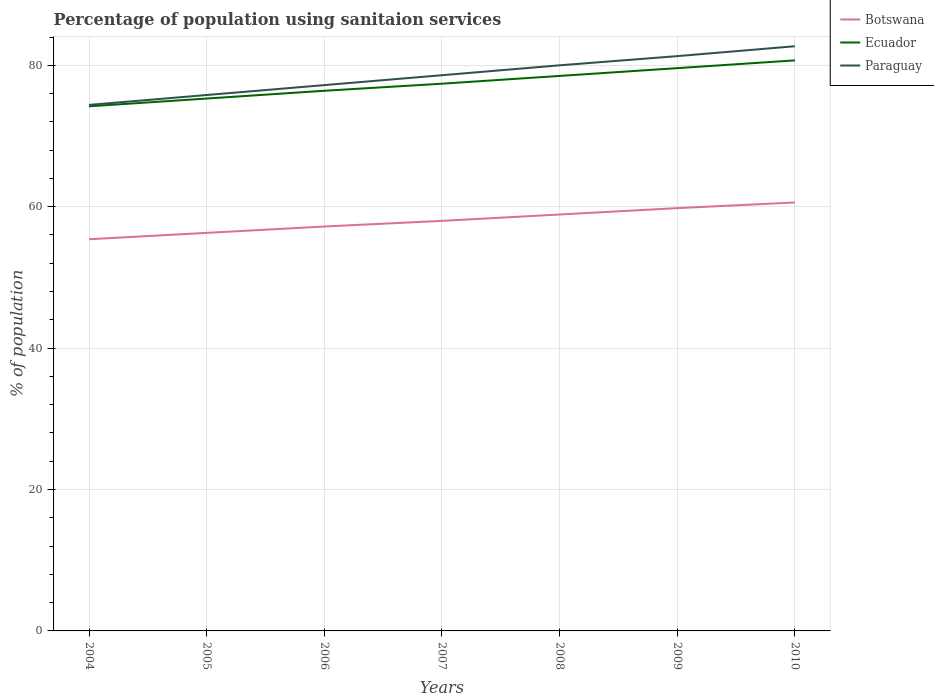How many different coloured lines are there?
Your answer should be very brief. 3. Does the line corresponding to Botswana intersect with the line corresponding to Ecuador?
Give a very brief answer. No. Across all years, what is the maximum percentage of population using sanitaion services in Paraguay?
Provide a succinct answer. 74.4. In which year was the percentage of population using sanitaion services in Ecuador maximum?
Your answer should be compact. 2004. What is the total percentage of population using sanitaion services in Ecuador in the graph?
Your answer should be compact. -5.4. What is the difference between the highest and the second highest percentage of population using sanitaion services in Botswana?
Provide a succinct answer. 5.2. What is the difference between the highest and the lowest percentage of population using sanitaion services in Ecuador?
Offer a very short reply. 3. How many years are there in the graph?
Provide a succinct answer. 7. Does the graph contain any zero values?
Offer a terse response. No. Does the graph contain grids?
Your answer should be compact. Yes. What is the title of the graph?
Provide a short and direct response. Percentage of population using sanitaion services. Does "Finland" appear as one of the legend labels in the graph?
Give a very brief answer. No. What is the label or title of the X-axis?
Offer a terse response. Years. What is the label or title of the Y-axis?
Provide a succinct answer. % of population. What is the % of population in Botswana in 2004?
Offer a very short reply. 55.4. What is the % of population in Ecuador in 2004?
Ensure brevity in your answer.  74.2. What is the % of population in Paraguay in 2004?
Provide a short and direct response. 74.4. What is the % of population in Botswana in 2005?
Ensure brevity in your answer.  56.3. What is the % of population of Ecuador in 2005?
Keep it short and to the point. 75.3. What is the % of population of Paraguay in 2005?
Offer a terse response. 75.8. What is the % of population in Botswana in 2006?
Offer a terse response. 57.2. What is the % of population in Ecuador in 2006?
Your answer should be compact. 76.4. What is the % of population of Paraguay in 2006?
Give a very brief answer. 77.2. What is the % of population in Ecuador in 2007?
Make the answer very short. 77.4. What is the % of population of Paraguay in 2007?
Your response must be concise. 78.6. What is the % of population in Botswana in 2008?
Ensure brevity in your answer.  58.9. What is the % of population of Ecuador in 2008?
Your answer should be compact. 78.5. What is the % of population of Botswana in 2009?
Your response must be concise. 59.8. What is the % of population of Ecuador in 2009?
Your response must be concise. 79.6. What is the % of population in Paraguay in 2009?
Your answer should be very brief. 81.3. What is the % of population of Botswana in 2010?
Your answer should be compact. 60.6. What is the % of population in Ecuador in 2010?
Give a very brief answer. 80.7. What is the % of population in Paraguay in 2010?
Offer a terse response. 82.7. Across all years, what is the maximum % of population of Botswana?
Provide a succinct answer. 60.6. Across all years, what is the maximum % of population in Ecuador?
Your response must be concise. 80.7. Across all years, what is the maximum % of population in Paraguay?
Make the answer very short. 82.7. Across all years, what is the minimum % of population of Botswana?
Offer a terse response. 55.4. Across all years, what is the minimum % of population of Ecuador?
Your response must be concise. 74.2. Across all years, what is the minimum % of population in Paraguay?
Ensure brevity in your answer.  74.4. What is the total % of population of Botswana in the graph?
Provide a succinct answer. 406.2. What is the total % of population in Ecuador in the graph?
Offer a very short reply. 542.1. What is the total % of population in Paraguay in the graph?
Provide a short and direct response. 550. What is the difference between the % of population in Ecuador in 2004 and that in 2006?
Keep it short and to the point. -2.2. What is the difference between the % of population in Botswana in 2004 and that in 2007?
Keep it short and to the point. -2.6. What is the difference between the % of population of Paraguay in 2004 and that in 2007?
Your response must be concise. -4.2. What is the difference between the % of population of Botswana in 2004 and that in 2008?
Make the answer very short. -3.5. What is the difference between the % of population in Ecuador in 2004 and that in 2008?
Your answer should be very brief. -4.3. What is the difference between the % of population in Botswana in 2004 and that in 2009?
Offer a very short reply. -4.4. What is the difference between the % of population of Botswana in 2004 and that in 2010?
Provide a short and direct response. -5.2. What is the difference between the % of population in Ecuador in 2004 and that in 2010?
Your response must be concise. -6.5. What is the difference between the % of population in Paraguay in 2004 and that in 2010?
Provide a succinct answer. -8.3. What is the difference between the % of population of Botswana in 2005 and that in 2007?
Keep it short and to the point. -1.7. What is the difference between the % of population of Ecuador in 2005 and that in 2007?
Make the answer very short. -2.1. What is the difference between the % of population in Paraguay in 2005 and that in 2007?
Keep it short and to the point. -2.8. What is the difference between the % of population in Ecuador in 2005 and that in 2008?
Offer a very short reply. -3.2. What is the difference between the % of population in Paraguay in 2005 and that in 2008?
Your answer should be very brief. -4.2. What is the difference between the % of population of Ecuador in 2005 and that in 2009?
Provide a succinct answer. -4.3. What is the difference between the % of population in Ecuador in 2005 and that in 2010?
Keep it short and to the point. -5.4. What is the difference between the % of population of Paraguay in 2005 and that in 2010?
Your answer should be compact. -6.9. What is the difference between the % of population in Ecuador in 2006 and that in 2007?
Make the answer very short. -1. What is the difference between the % of population in Ecuador in 2006 and that in 2009?
Your answer should be very brief. -3.2. What is the difference between the % of population in Paraguay in 2006 and that in 2009?
Ensure brevity in your answer.  -4.1. What is the difference between the % of population of Paraguay in 2006 and that in 2010?
Ensure brevity in your answer.  -5.5. What is the difference between the % of population of Botswana in 2007 and that in 2008?
Offer a very short reply. -0.9. What is the difference between the % of population in Paraguay in 2007 and that in 2008?
Offer a terse response. -1.4. What is the difference between the % of population of Botswana in 2007 and that in 2009?
Give a very brief answer. -1.8. What is the difference between the % of population of Paraguay in 2007 and that in 2009?
Make the answer very short. -2.7. What is the difference between the % of population of Ecuador in 2007 and that in 2010?
Provide a short and direct response. -3.3. What is the difference between the % of population in Botswana in 2008 and that in 2009?
Provide a succinct answer. -0.9. What is the difference between the % of population of Botswana in 2008 and that in 2010?
Provide a short and direct response. -1.7. What is the difference between the % of population in Paraguay in 2008 and that in 2010?
Make the answer very short. -2.7. What is the difference between the % of population of Ecuador in 2009 and that in 2010?
Offer a very short reply. -1.1. What is the difference between the % of population of Botswana in 2004 and the % of population of Ecuador in 2005?
Provide a succinct answer. -19.9. What is the difference between the % of population of Botswana in 2004 and the % of population of Paraguay in 2005?
Offer a very short reply. -20.4. What is the difference between the % of population of Botswana in 2004 and the % of population of Paraguay in 2006?
Offer a very short reply. -21.8. What is the difference between the % of population in Ecuador in 2004 and the % of population in Paraguay in 2006?
Ensure brevity in your answer.  -3. What is the difference between the % of population in Botswana in 2004 and the % of population in Ecuador in 2007?
Offer a very short reply. -22. What is the difference between the % of population of Botswana in 2004 and the % of population of Paraguay in 2007?
Make the answer very short. -23.2. What is the difference between the % of population in Ecuador in 2004 and the % of population in Paraguay in 2007?
Ensure brevity in your answer.  -4.4. What is the difference between the % of population of Botswana in 2004 and the % of population of Ecuador in 2008?
Keep it short and to the point. -23.1. What is the difference between the % of population of Botswana in 2004 and the % of population of Paraguay in 2008?
Your answer should be compact. -24.6. What is the difference between the % of population in Botswana in 2004 and the % of population in Ecuador in 2009?
Keep it short and to the point. -24.2. What is the difference between the % of population of Botswana in 2004 and the % of population of Paraguay in 2009?
Offer a very short reply. -25.9. What is the difference between the % of population in Botswana in 2004 and the % of population in Ecuador in 2010?
Provide a succinct answer. -25.3. What is the difference between the % of population in Botswana in 2004 and the % of population in Paraguay in 2010?
Offer a terse response. -27.3. What is the difference between the % of population of Botswana in 2005 and the % of population of Ecuador in 2006?
Offer a very short reply. -20.1. What is the difference between the % of population in Botswana in 2005 and the % of population in Paraguay in 2006?
Provide a succinct answer. -20.9. What is the difference between the % of population in Ecuador in 2005 and the % of population in Paraguay in 2006?
Give a very brief answer. -1.9. What is the difference between the % of population of Botswana in 2005 and the % of population of Ecuador in 2007?
Offer a very short reply. -21.1. What is the difference between the % of population of Botswana in 2005 and the % of population of Paraguay in 2007?
Your answer should be compact. -22.3. What is the difference between the % of population in Botswana in 2005 and the % of population in Ecuador in 2008?
Your answer should be very brief. -22.2. What is the difference between the % of population in Botswana in 2005 and the % of population in Paraguay in 2008?
Your answer should be very brief. -23.7. What is the difference between the % of population of Botswana in 2005 and the % of population of Ecuador in 2009?
Your answer should be compact. -23.3. What is the difference between the % of population in Botswana in 2005 and the % of population in Paraguay in 2009?
Keep it short and to the point. -25. What is the difference between the % of population in Botswana in 2005 and the % of population in Ecuador in 2010?
Give a very brief answer. -24.4. What is the difference between the % of population of Botswana in 2005 and the % of population of Paraguay in 2010?
Ensure brevity in your answer.  -26.4. What is the difference between the % of population of Ecuador in 2005 and the % of population of Paraguay in 2010?
Your response must be concise. -7.4. What is the difference between the % of population of Botswana in 2006 and the % of population of Ecuador in 2007?
Your response must be concise. -20.2. What is the difference between the % of population of Botswana in 2006 and the % of population of Paraguay in 2007?
Give a very brief answer. -21.4. What is the difference between the % of population of Ecuador in 2006 and the % of population of Paraguay in 2007?
Keep it short and to the point. -2.2. What is the difference between the % of population of Botswana in 2006 and the % of population of Ecuador in 2008?
Make the answer very short. -21.3. What is the difference between the % of population of Botswana in 2006 and the % of population of Paraguay in 2008?
Offer a terse response. -22.8. What is the difference between the % of population in Botswana in 2006 and the % of population in Ecuador in 2009?
Your answer should be compact. -22.4. What is the difference between the % of population in Botswana in 2006 and the % of population in Paraguay in 2009?
Offer a very short reply. -24.1. What is the difference between the % of population in Ecuador in 2006 and the % of population in Paraguay in 2009?
Your response must be concise. -4.9. What is the difference between the % of population of Botswana in 2006 and the % of population of Ecuador in 2010?
Your answer should be compact. -23.5. What is the difference between the % of population of Botswana in 2006 and the % of population of Paraguay in 2010?
Offer a terse response. -25.5. What is the difference between the % of population in Ecuador in 2006 and the % of population in Paraguay in 2010?
Make the answer very short. -6.3. What is the difference between the % of population in Botswana in 2007 and the % of population in Ecuador in 2008?
Your answer should be compact. -20.5. What is the difference between the % of population in Botswana in 2007 and the % of population in Paraguay in 2008?
Offer a very short reply. -22. What is the difference between the % of population of Ecuador in 2007 and the % of population of Paraguay in 2008?
Make the answer very short. -2.6. What is the difference between the % of population in Botswana in 2007 and the % of population in Ecuador in 2009?
Your answer should be very brief. -21.6. What is the difference between the % of population of Botswana in 2007 and the % of population of Paraguay in 2009?
Keep it short and to the point. -23.3. What is the difference between the % of population in Ecuador in 2007 and the % of population in Paraguay in 2009?
Give a very brief answer. -3.9. What is the difference between the % of population of Botswana in 2007 and the % of population of Ecuador in 2010?
Keep it short and to the point. -22.7. What is the difference between the % of population in Botswana in 2007 and the % of population in Paraguay in 2010?
Ensure brevity in your answer.  -24.7. What is the difference between the % of population of Ecuador in 2007 and the % of population of Paraguay in 2010?
Offer a very short reply. -5.3. What is the difference between the % of population in Botswana in 2008 and the % of population in Ecuador in 2009?
Give a very brief answer. -20.7. What is the difference between the % of population of Botswana in 2008 and the % of population of Paraguay in 2009?
Make the answer very short. -22.4. What is the difference between the % of population of Botswana in 2008 and the % of population of Ecuador in 2010?
Your response must be concise. -21.8. What is the difference between the % of population in Botswana in 2008 and the % of population in Paraguay in 2010?
Your answer should be very brief. -23.8. What is the difference between the % of population of Ecuador in 2008 and the % of population of Paraguay in 2010?
Your response must be concise. -4.2. What is the difference between the % of population in Botswana in 2009 and the % of population in Ecuador in 2010?
Provide a short and direct response. -20.9. What is the difference between the % of population in Botswana in 2009 and the % of population in Paraguay in 2010?
Your response must be concise. -22.9. What is the difference between the % of population of Ecuador in 2009 and the % of population of Paraguay in 2010?
Provide a succinct answer. -3.1. What is the average % of population in Botswana per year?
Your answer should be very brief. 58.03. What is the average % of population of Ecuador per year?
Ensure brevity in your answer.  77.44. What is the average % of population in Paraguay per year?
Your answer should be compact. 78.57. In the year 2004, what is the difference between the % of population in Botswana and % of population in Ecuador?
Your answer should be compact. -18.8. In the year 2005, what is the difference between the % of population in Botswana and % of population in Paraguay?
Provide a short and direct response. -19.5. In the year 2005, what is the difference between the % of population of Ecuador and % of population of Paraguay?
Provide a short and direct response. -0.5. In the year 2006, what is the difference between the % of population of Botswana and % of population of Ecuador?
Offer a terse response. -19.2. In the year 2006, what is the difference between the % of population in Botswana and % of population in Paraguay?
Your response must be concise. -20. In the year 2007, what is the difference between the % of population of Botswana and % of population of Ecuador?
Provide a short and direct response. -19.4. In the year 2007, what is the difference between the % of population of Botswana and % of population of Paraguay?
Your answer should be very brief. -20.6. In the year 2008, what is the difference between the % of population of Botswana and % of population of Ecuador?
Offer a very short reply. -19.6. In the year 2008, what is the difference between the % of population in Botswana and % of population in Paraguay?
Provide a succinct answer. -21.1. In the year 2009, what is the difference between the % of population of Botswana and % of population of Ecuador?
Give a very brief answer. -19.8. In the year 2009, what is the difference between the % of population of Botswana and % of population of Paraguay?
Keep it short and to the point. -21.5. In the year 2010, what is the difference between the % of population in Botswana and % of population in Ecuador?
Offer a terse response. -20.1. In the year 2010, what is the difference between the % of population of Botswana and % of population of Paraguay?
Provide a succinct answer. -22.1. In the year 2010, what is the difference between the % of population of Ecuador and % of population of Paraguay?
Your response must be concise. -2. What is the ratio of the % of population in Ecuador in 2004 to that in 2005?
Keep it short and to the point. 0.99. What is the ratio of the % of population of Paraguay in 2004 to that in 2005?
Your response must be concise. 0.98. What is the ratio of the % of population in Botswana in 2004 to that in 2006?
Provide a succinct answer. 0.97. What is the ratio of the % of population of Ecuador in 2004 to that in 2006?
Keep it short and to the point. 0.97. What is the ratio of the % of population in Paraguay in 2004 to that in 2006?
Make the answer very short. 0.96. What is the ratio of the % of population of Botswana in 2004 to that in 2007?
Provide a short and direct response. 0.96. What is the ratio of the % of population in Ecuador in 2004 to that in 2007?
Make the answer very short. 0.96. What is the ratio of the % of population of Paraguay in 2004 to that in 2007?
Ensure brevity in your answer.  0.95. What is the ratio of the % of population in Botswana in 2004 to that in 2008?
Give a very brief answer. 0.94. What is the ratio of the % of population of Ecuador in 2004 to that in 2008?
Ensure brevity in your answer.  0.95. What is the ratio of the % of population in Paraguay in 2004 to that in 2008?
Your response must be concise. 0.93. What is the ratio of the % of population in Botswana in 2004 to that in 2009?
Your response must be concise. 0.93. What is the ratio of the % of population of Ecuador in 2004 to that in 2009?
Offer a terse response. 0.93. What is the ratio of the % of population in Paraguay in 2004 to that in 2009?
Keep it short and to the point. 0.92. What is the ratio of the % of population of Botswana in 2004 to that in 2010?
Provide a succinct answer. 0.91. What is the ratio of the % of population in Ecuador in 2004 to that in 2010?
Offer a very short reply. 0.92. What is the ratio of the % of population in Paraguay in 2004 to that in 2010?
Your answer should be compact. 0.9. What is the ratio of the % of population of Botswana in 2005 to that in 2006?
Provide a succinct answer. 0.98. What is the ratio of the % of population of Ecuador in 2005 to that in 2006?
Your answer should be very brief. 0.99. What is the ratio of the % of population of Paraguay in 2005 to that in 2006?
Give a very brief answer. 0.98. What is the ratio of the % of population of Botswana in 2005 to that in 2007?
Provide a succinct answer. 0.97. What is the ratio of the % of population of Ecuador in 2005 to that in 2007?
Offer a very short reply. 0.97. What is the ratio of the % of population in Paraguay in 2005 to that in 2007?
Your answer should be compact. 0.96. What is the ratio of the % of population of Botswana in 2005 to that in 2008?
Provide a succinct answer. 0.96. What is the ratio of the % of population of Ecuador in 2005 to that in 2008?
Offer a terse response. 0.96. What is the ratio of the % of population in Paraguay in 2005 to that in 2008?
Offer a terse response. 0.95. What is the ratio of the % of population in Botswana in 2005 to that in 2009?
Provide a short and direct response. 0.94. What is the ratio of the % of population in Ecuador in 2005 to that in 2009?
Ensure brevity in your answer.  0.95. What is the ratio of the % of population of Paraguay in 2005 to that in 2009?
Your answer should be very brief. 0.93. What is the ratio of the % of population of Botswana in 2005 to that in 2010?
Provide a short and direct response. 0.93. What is the ratio of the % of population in Ecuador in 2005 to that in 2010?
Provide a short and direct response. 0.93. What is the ratio of the % of population in Paraguay in 2005 to that in 2010?
Keep it short and to the point. 0.92. What is the ratio of the % of population in Botswana in 2006 to that in 2007?
Provide a succinct answer. 0.99. What is the ratio of the % of population in Ecuador in 2006 to that in 2007?
Make the answer very short. 0.99. What is the ratio of the % of population of Paraguay in 2006 to that in 2007?
Offer a terse response. 0.98. What is the ratio of the % of population of Botswana in 2006 to that in 2008?
Make the answer very short. 0.97. What is the ratio of the % of population of Ecuador in 2006 to that in 2008?
Provide a succinct answer. 0.97. What is the ratio of the % of population of Paraguay in 2006 to that in 2008?
Give a very brief answer. 0.96. What is the ratio of the % of population of Botswana in 2006 to that in 2009?
Keep it short and to the point. 0.96. What is the ratio of the % of population of Ecuador in 2006 to that in 2009?
Your response must be concise. 0.96. What is the ratio of the % of population of Paraguay in 2006 to that in 2009?
Ensure brevity in your answer.  0.95. What is the ratio of the % of population in Botswana in 2006 to that in 2010?
Offer a very short reply. 0.94. What is the ratio of the % of population in Ecuador in 2006 to that in 2010?
Provide a short and direct response. 0.95. What is the ratio of the % of population in Paraguay in 2006 to that in 2010?
Give a very brief answer. 0.93. What is the ratio of the % of population in Botswana in 2007 to that in 2008?
Your response must be concise. 0.98. What is the ratio of the % of population of Ecuador in 2007 to that in 2008?
Make the answer very short. 0.99. What is the ratio of the % of population in Paraguay in 2007 to that in 2008?
Your answer should be compact. 0.98. What is the ratio of the % of population in Botswana in 2007 to that in 2009?
Keep it short and to the point. 0.97. What is the ratio of the % of population in Ecuador in 2007 to that in 2009?
Ensure brevity in your answer.  0.97. What is the ratio of the % of population of Paraguay in 2007 to that in 2009?
Ensure brevity in your answer.  0.97. What is the ratio of the % of population of Botswana in 2007 to that in 2010?
Offer a terse response. 0.96. What is the ratio of the % of population in Ecuador in 2007 to that in 2010?
Your answer should be very brief. 0.96. What is the ratio of the % of population of Paraguay in 2007 to that in 2010?
Offer a very short reply. 0.95. What is the ratio of the % of population in Botswana in 2008 to that in 2009?
Your answer should be very brief. 0.98. What is the ratio of the % of population in Ecuador in 2008 to that in 2009?
Offer a very short reply. 0.99. What is the ratio of the % of population in Botswana in 2008 to that in 2010?
Ensure brevity in your answer.  0.97. What is the ratio of the % of population in Ecuador in 2008 to that in 2010?
Give a very brief answer. 0.97. What is the ratio of the % of population in Paraguay in 2008 to that in 2010?
Provide a short and direct response. 0.97. What is the ratio of the % of population of Ecuador in 2009 to that in 2010?
Ensure brevity in your answer.  0.99. What is the ratio of the % of population in Paraguay in 2009 to that in 2010?
Provide a short and direct response. 0.98. What is the difference between the highest and the second highest % of population in Ecuador?
Your answer should be compact. 1.1. What is the difference between the highest and the lowest % of population of Botswana?
Provide a short and direct response. 5.2. 